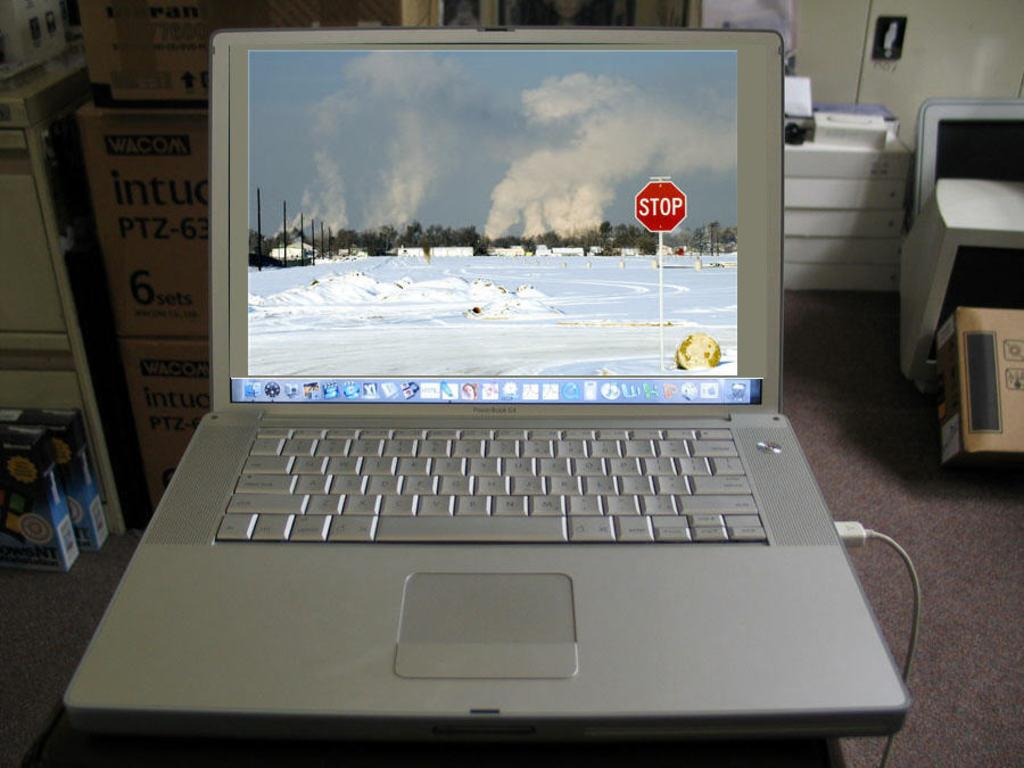<image>
Relay a brief, clear account of the picture shown. A computer opened to the desktop where there is a STOP sign. 